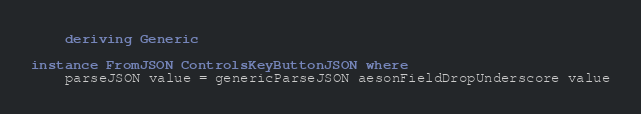Convert code to text. <code><loc_0><loc_0><loc_500><loc_500><_Haskell_>    deriving Generic

instance FromJSON ControlsKeyButtonJSON where
    parseJSON value = genericParseJSON aesonFieldDropUnderscore value
</code> 